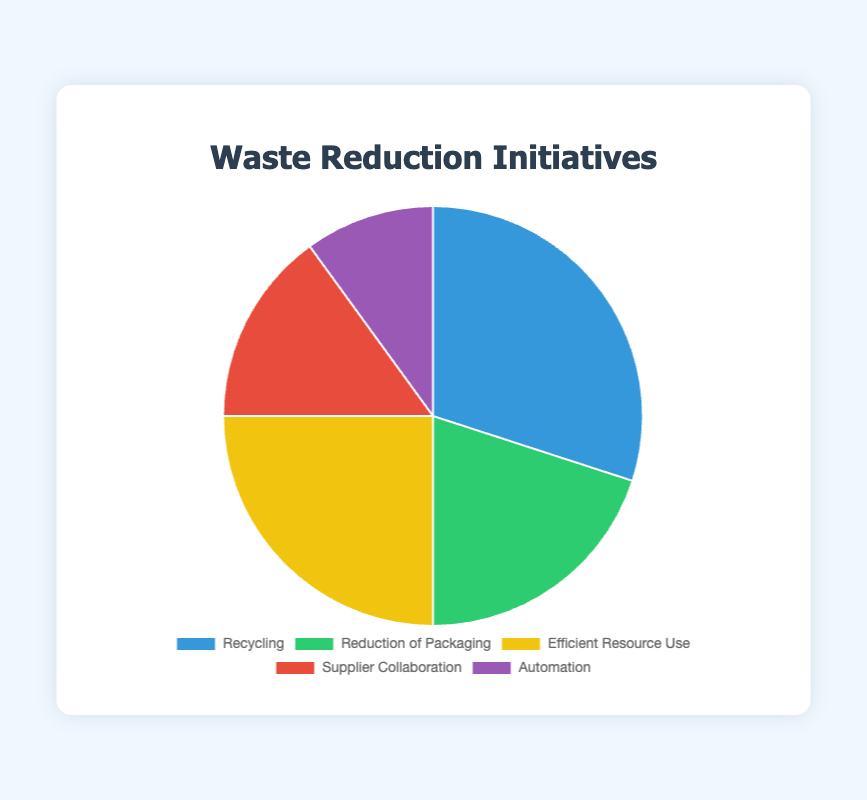What is the most significant waste reduction initiative based on the proportion in the pie chart? The most significant waste reduction initiative is determined by looking at the category with the largest section in the pie chart. The biggest section corresponds to Recycling, which takes up 30% of the total.
Answer: Recycling What is the combined proportion of waste reduction efforts for Efficient Resource Use and Automation? To find the combined proportion, add the proportions of Efficient Resource Use and Automation. Efficient Resource Use is 25% and Automation is 10%. Thus, 25% + 10% = 35%.
Answer: 35% By how much is the proportion of Recycling greater than the proportion of Supplier Collaboration? Subtract the proportion of Supplier Collaboration from the proportion of Recycling. Recycling is 30% and Supplier Collaboration is 15%. Thus, 30% - 15% = 15%.
Answer: 15% Which categories together make up half of the total waste reduction efforts? Look for categories whose combined proportions add up to 50%. Recycling is 30%, and Reduction of Packaging is 20%. Together, they add up to 30% + 20% = 50%.
Answer: Recycling and Reduction of Packaging What proportion of waste reduction efforts is dedicated to initiatives represented by warm colors (yellow, red) on the pie chart? Identify the proportions of categories represented by warm colors: Efficient Resource Use (yellow) is 25% and Supplier Collaboration (red) is 15%. Adding these gives 25% + 15% = 40%.
Answer: 40% Is the proportion for Reduction of Packaging greater than or less than Automation, and by how much? Compare the proportions for Reduction of Packaging (20%) and Automation (10%). Reduction of Packaging is greater. The difference is 20% - 10% = 10%.
Answer: Greater by 10% Which categories combined have a smaller proportion than the proportion dedicated to Recycling alone? Identify the categories and their proportions: Reduction of Packaging (20%), Supplier Collaboration (15%), and Automation (10%). Check their combined total: 20% + 15% + 10% = 45%. Since Recycling alone is 30%, we need combinations with individual sums under 30%. Supplier Collaboration (15%) and Automation (10%) combined give: 15% + 10% = 25%, which is smaller than 30%.
Answer: Supplier Collaboration and Automation What is the average proportion of the waste reduction initiatives? To find the average proportion, sum all the proportions and then divide by the number of initiatives. The sum is 100% (30% + 20% + 25% + 15% + 10%), and there are 5 initiatives. Thus, 100% / 5 = 20%.
Answer: 20% Which initiative has the second-lowest proportion in the pie chart? Arrange the categories by proportion in ascending order: Automation (10%), Supplier Collaboration (15%), Reduction of Packaging (20%), Efficient Resource Use (25%), and Recycling (30%). The second-lowest proportion is Supplier Collaboration at 15%.
Answer: Supplier Collaboration What percentage more of efforts is allocated to Efficient Resource Use compared to Automation? Subtract the proportion of Automation from the proportion of Efficient Resource Use, then divide by the proportion of Automation and multiply by 100 to get the percentage increase. Efficient Resource Use is 25% and Automation is 10%. (25% - 10%) / 10% * 100 = 150%.
Answer: 150% 